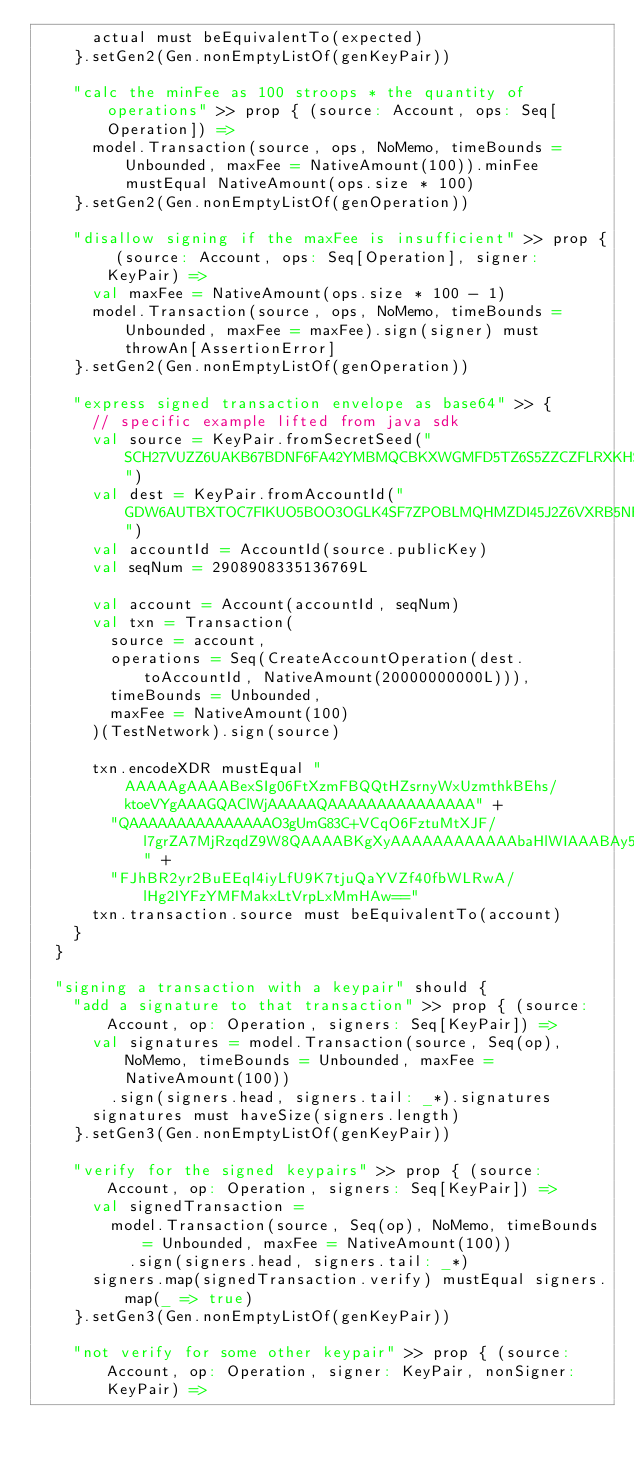Convert code to text. <code><loc_0><loc_0><loc_500><loc_500><_Scala_>      actual must beEquivalentTo(expected)
    }.setGen2(Gen.nonEmptyListOf(genKeyPair))

    "calc the minFee as 100 stroops * the quantity of operations" >> prop { (source: Account, ops: Seq[Operation]) =>
      model.Transaction(source, ops, NoMemo, timeBounds = Unbounded, maxFee = NativeAmount(100)).minFee mustEqual NativeAmount(ops.size * 100)
    }.setGen2(Gen.nonEmptyListOf(genOperation))

    "disallow signing if the maxFee is insufficient" >> prop { (source: Account, ops: Seq[Operation], signer: KeyPair) =>
      val maxFee = NativeAmount(ops.size * 100 - 1)
      model.Transaction(source, ops, NoMemo, timeBounds = Unbounded, maxFee = maxFee).sign(signer) must throwAn[AssertionError]
    }.setGen2(Gen.nonEmptyListOf(genOperation))

    "express signed transaction envelope as base64" >> {
      // specific example lifted from java sdk
      val source = KeyPair.fromSecretSeed("SCH27VUZZ6UAKB67BDNF6FA42YMBMQCBKXWGMFD5TZ6S5ZZCZFLRXKHS")
      val dest = KeyPair.fromAccountId("GDW6AUTBXTOC7FIKUO5BOO3OGLK4SF7ZPOBLMQHMZDI45J2Z6VXRB5NR")
      val accountId = AccountId(source.publicKey)
      val seqNum = 2908908335136769L

      val account = Account(accountId, seqNum)
      val txn = Transaction(
        source = account,
        operations = Seq(CreateAccountOperation(dest.toAccountId, NativeAmount(20000000000L))),
        timeBounds = Unbounded,
        maxFee = NativeAmount(100)
      )(TestNetwork).sign(source)

      txn.encodeXDR mustEqual "AAAAAgAAAABexSIg06FtXzmFBQQtHZsrnyWxUzmthkBEhs/ktoeVYgAAAGQAClWjAAAAAQAAAAAAAAAAAAAAA" +
        "QAAAAAAAAAAAAAAAO3gUmG83C+VCqO6FztuMtXJF/l7grZA7MjRzqdZ9W8QAAAABKgXyAAAAAAAAAAAAbaHlWIAAABAy5IvTou9NDetC6PI" +
        "FJhBR2yr2BuEEql4iyLfU9K7tjuQaYVZf40fbWLRwA/lHg2IYFzYMFMakxLtVrpLxMmHAw=="
      txn.transaction.source must beEquivalentTo(account)
    }
  }

  "signing a transaction with a keypair" should {
    "add a signature to that transaction" >> prop { (source: Account, op: Operation, signers: Seq[KeyPair]) =>
      val signatures = model.Transaction(source, Seq(op), NoMemo, timeBounds = Unbounded, maxFee = NativeAmount(100))
        .sign(signers.head, signers.tail: _*).signatures
      signatures must haveSize(signers.length)
    }.setGen3(Gen.nonEmptyListOf(genKeyPair))

    "verify for the signed keypairs" >> prop { (source: Account, op: Operation, signers: Seq[KeyPair]) =>
      val signedTransaction =
        model.Transaction(source, Seq(op), NoMemo, timeBounds = Unbounded, maxFee = NativeAmount(100))
          .sign(signers.head, signers.tail: _*)
      signers.map(signedTransaction.verify) mustEqual signers.map(_ => true)
    }.setGen3(Gen.nonEmptyListOf(genKeyPair))

    "not verify for some other keypair" >> prop { (source: Account, op: Operation, signer: KeyPair, nonSigner: KeyPair) =></code> 